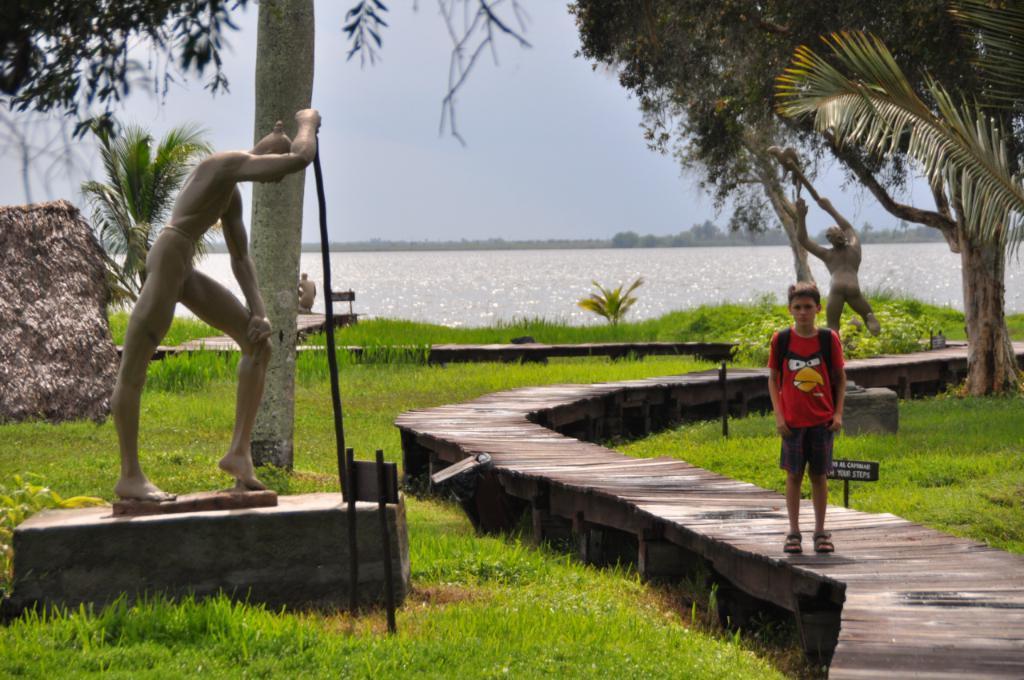In one or two sentences, can you explain what this image depicts? In this Image I can see the person standing on the wooden surface. The person is wearing the red color dress. To the side there are many statues which are in grey color. I can see many trees, water and the sky. 